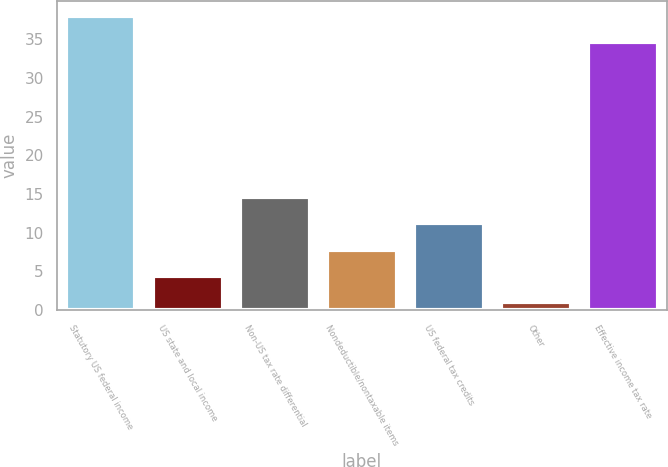Convert chart. <chart><loc_0><loc_0><loc_500><loc_500><bar_chart><fcel>Statutory US federal income<fcel>US state and local income<fcel>Non-US tax rate differential<fcel>Nondeductible/nontaxable items<fcel>US federal tax credits<fcel>Other<fcel>Effective income tax rate<nl><fcel>38<fcel>4.4<fcel>14.6<fcel>7.8<fcel>11.2<fcel>1<fcel>34.6<nl></chart> 